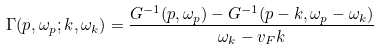Convert formula to latex. <formula><loc_0><loc_0><loc_500><loc_500>\Gamma ( p , \omega _ { p } ; k , \omega _ { k } ) = \frac { G ^ { - 1 } ( p , \omega _ { p } ) - G ^ { - 1 } ( p - k , \omega _ { p } - \omega _ { k } ) } { \omega _ { k } - v _ { F } k }</formula> 